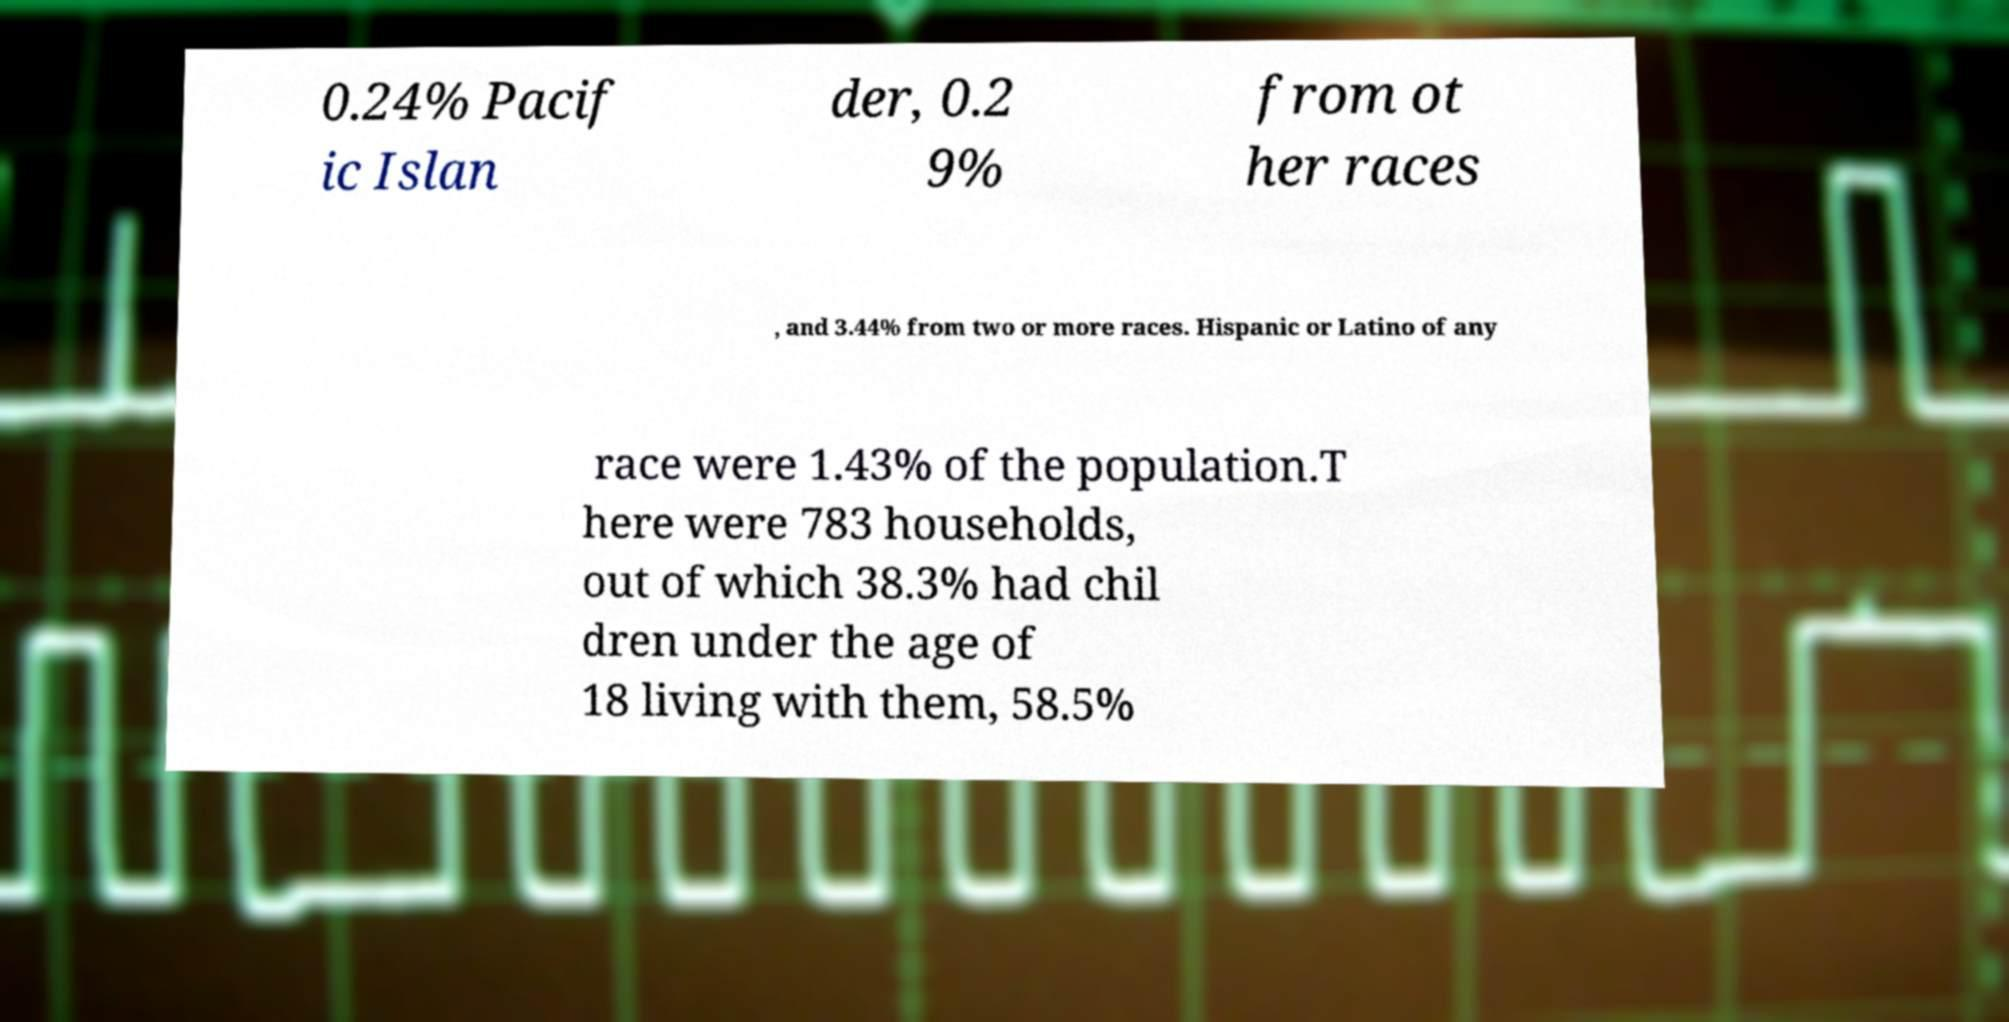Please identify and transcribe the text found in this image. 0.24% Pacif ic Islan der, 0.2 9% from ot her races , and 3.44% from two or more races. Hispanic or Latino of any race were 1.43% of the population.T here were 783 households, out of which 38.3% had chil dren under the age of 18 living with them, 58.5% 